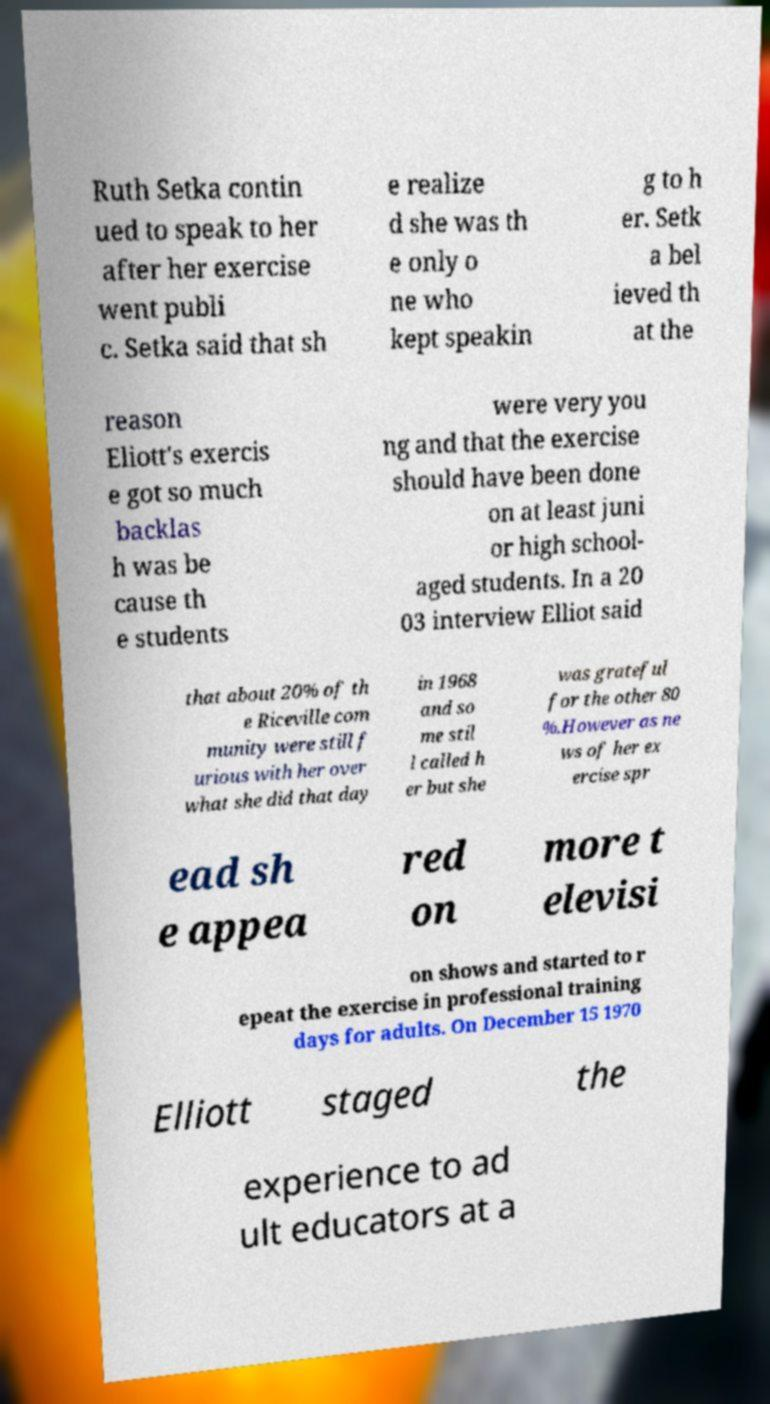Please identify and transcribe the text found in this image. Ruth Setka contin ued to speak to her after her exercise went publi c. Setka said that sh e realize d she was th e only o ne who kept speakin g to h er. Setk a bel ieved th at the reason Eliott's exercis e got so much backlas h was be cause th e students were very you ng and that the exercise should have been done on at least juni or high school- aged students. In a 20 03 interview Elliot said that about 20% of th e Riceville com munity were still f urious with her over what she did that day in 1968 and so me stil l called h er but she was grateful for the other 80 %.However as ne ws of her ex ercise spr ead sh e appea red on more t elevisi on shows and started to r epeat the exercise in professional training days for adults. On December 15 1970 Elliott staged the experience to ad ult educators at a 